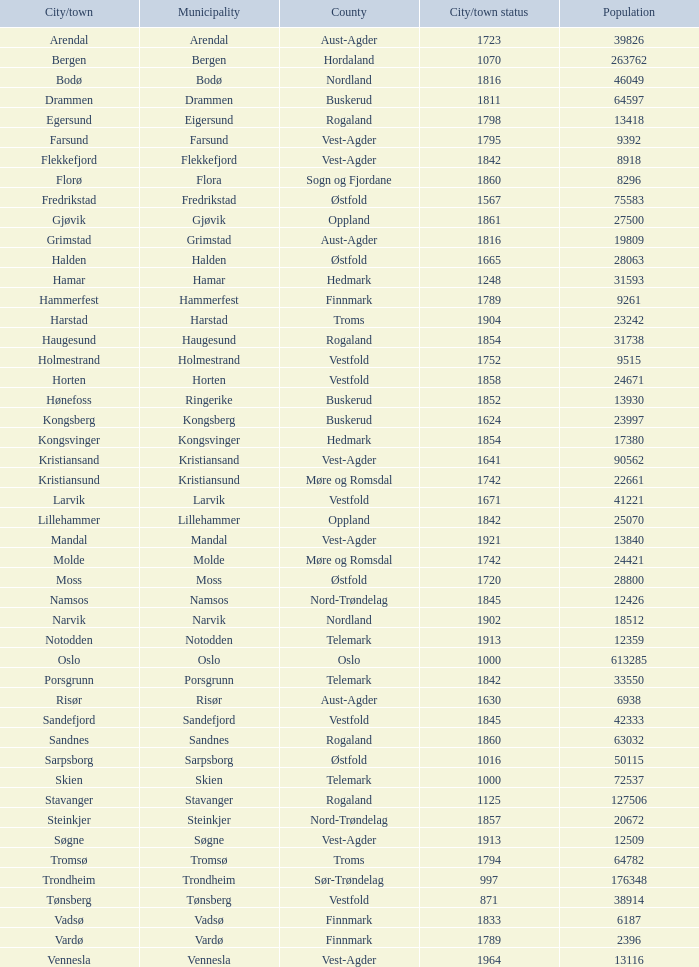What are the city/town settlements in the municipality of moss? Moss. 